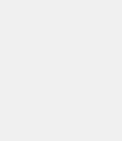Convert code to text. <code><loc_0><loc_0><loc_500><loc_500><_C_>
</code> 